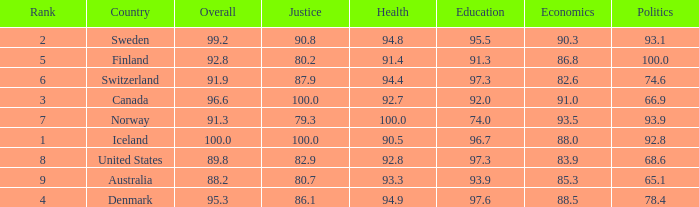What's the country with health being 91.4 Finland. 